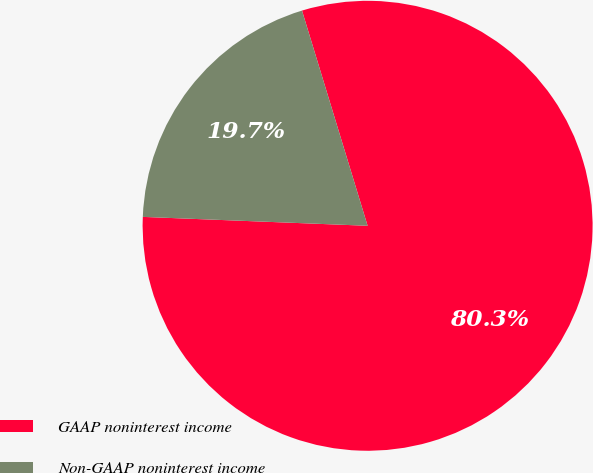Convert chart. <chart><loc_0><loc_0><loc_500><loc_500><pie_chart><fcel>GAAP noninterest income<fcel>Non-GAAP noninterest income<nl><fcel>80.34%<fcel>19.66%<nl></chart> 